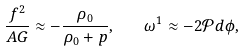<formula> <loc_0><loc_0><loc_500><loc_500>\frac { f ^ { 2 } } { A G } \approx - \frac { \rho _ { 0 } } { \rho _ { 0 } + p } , \quad \omega ^ { 1 } \approx - 2 \mathcal { P } d \phi ,</formula> 